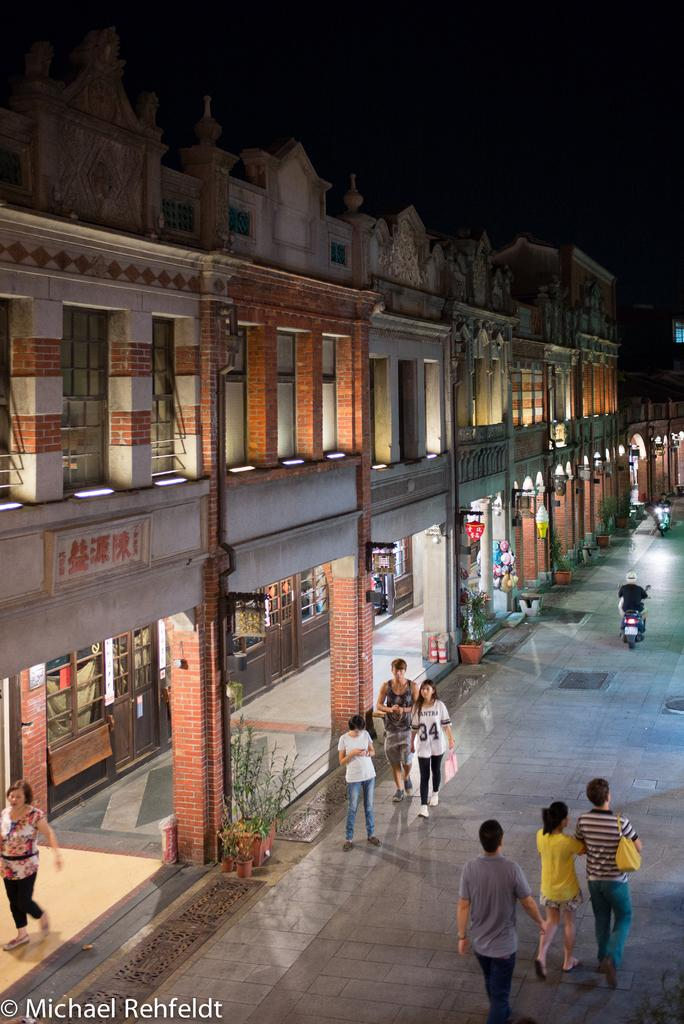Who can be seen at the bottom side of the image? There are people at the bottom side of the image. What type of structures are present in the image? There are stalls and buildings in the image. What can be seen on the walls or surfaces in the image? There are posters in the image. What type of vegetation is visible in the image? There are plants in the image. What type of farming equipment can be seen in the image? There is no farming equipment present in the image. What kind of detail can be seen on the posters in the image? The provided facts do not include information about the posters, but they do not mention any specific details. 